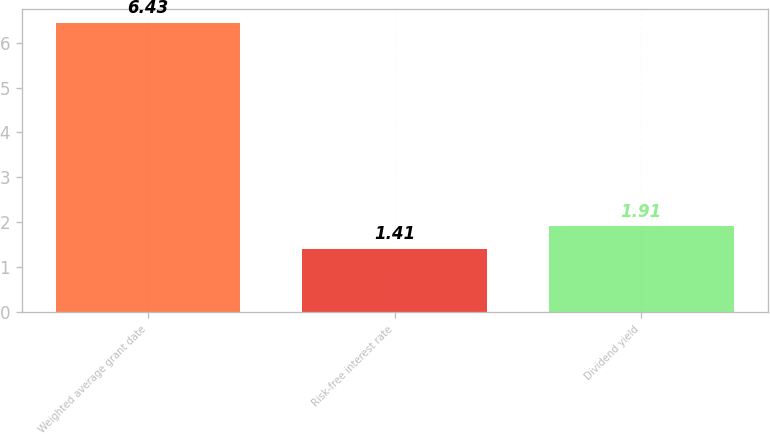<chart> <loc_0><loc_0><loc_500><loc_500><bar_chart><fcel>Weighted average grant date<fcel>Risk-free interest rate<fcel>Dividend yield<nl><fcel>6.43<fcel>1.41<fcel>1.91<nl></chart> 